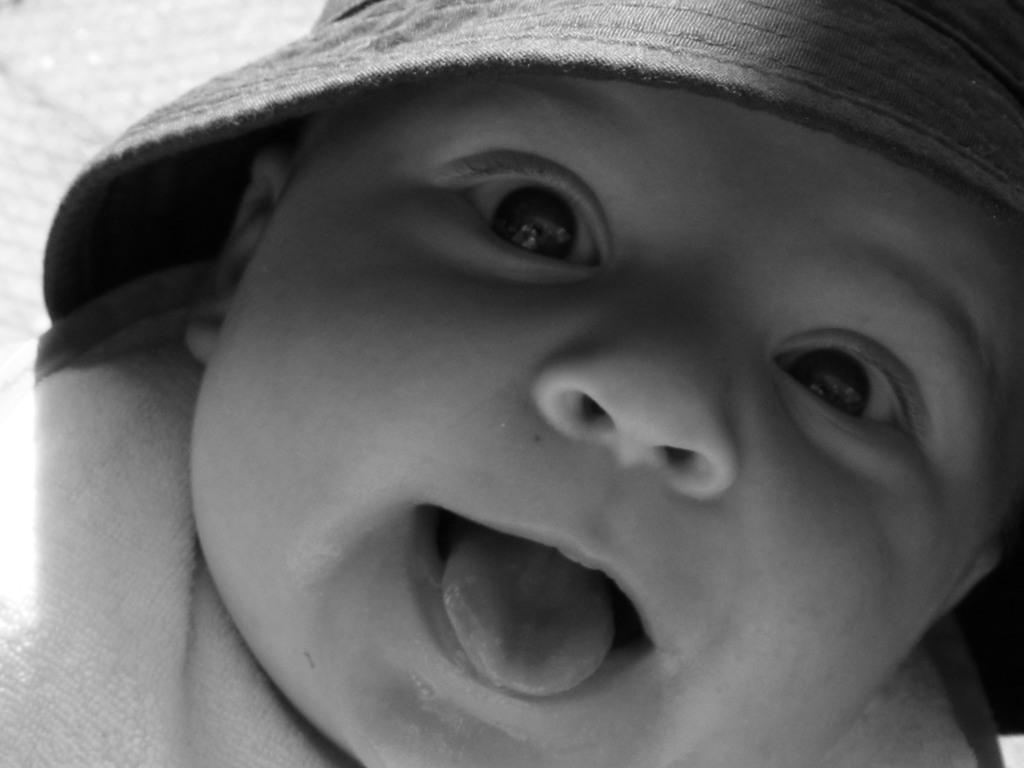What is the main subject of the picture? The main subject of the picture is a baby. What is the baby doing in the picture? The baby is showing his tongue. What is the baby wearing on his head? The baby is wearing a cap. What type of vase is visible in the background of the image? There is no vase present in the image; it features a baby showing his tongue and wearing a cap. How much does the silver parcel weigh in the image? There is no silver parcel present in the image. 